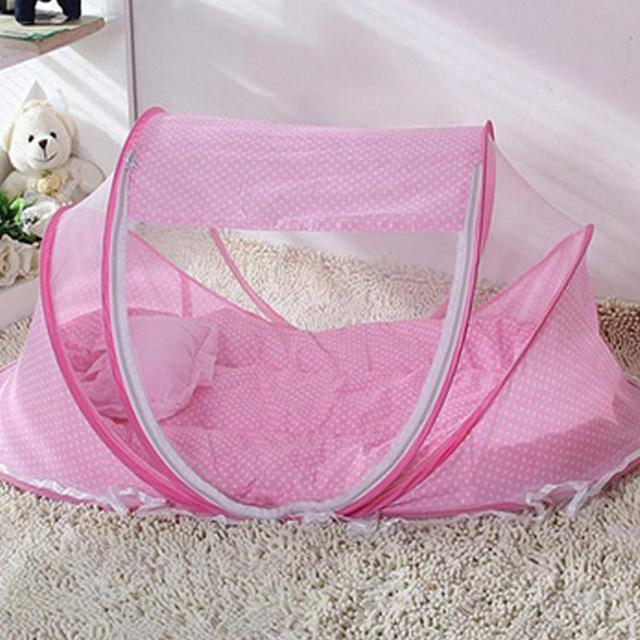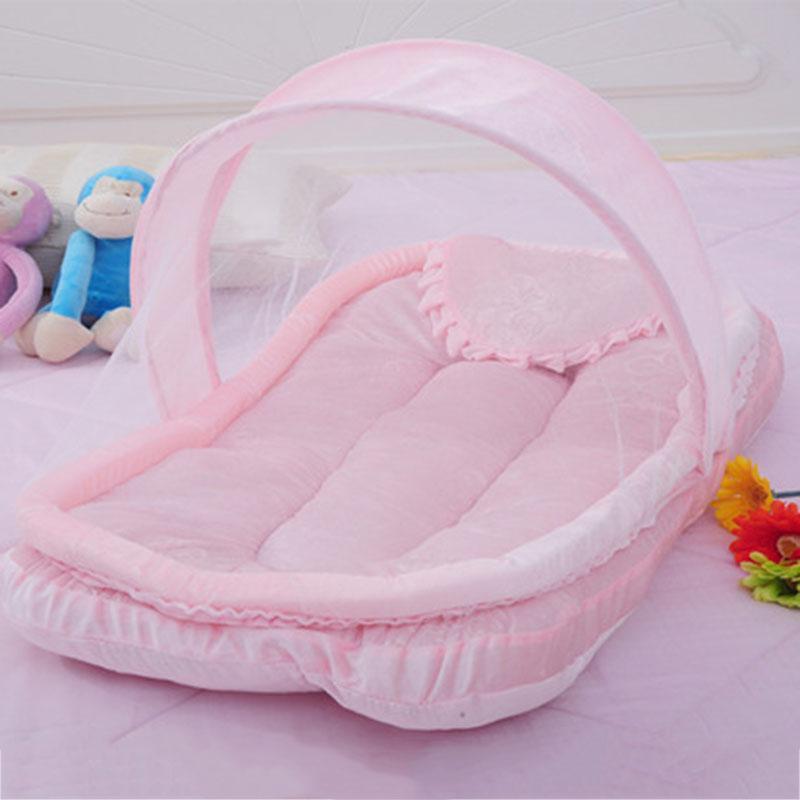The first image is the image on the left, the second image is the image on the right. Examine the images to the left and right. Is the description "One of the baby sleeper items is blue." accurate? Answer yes or no. No. 